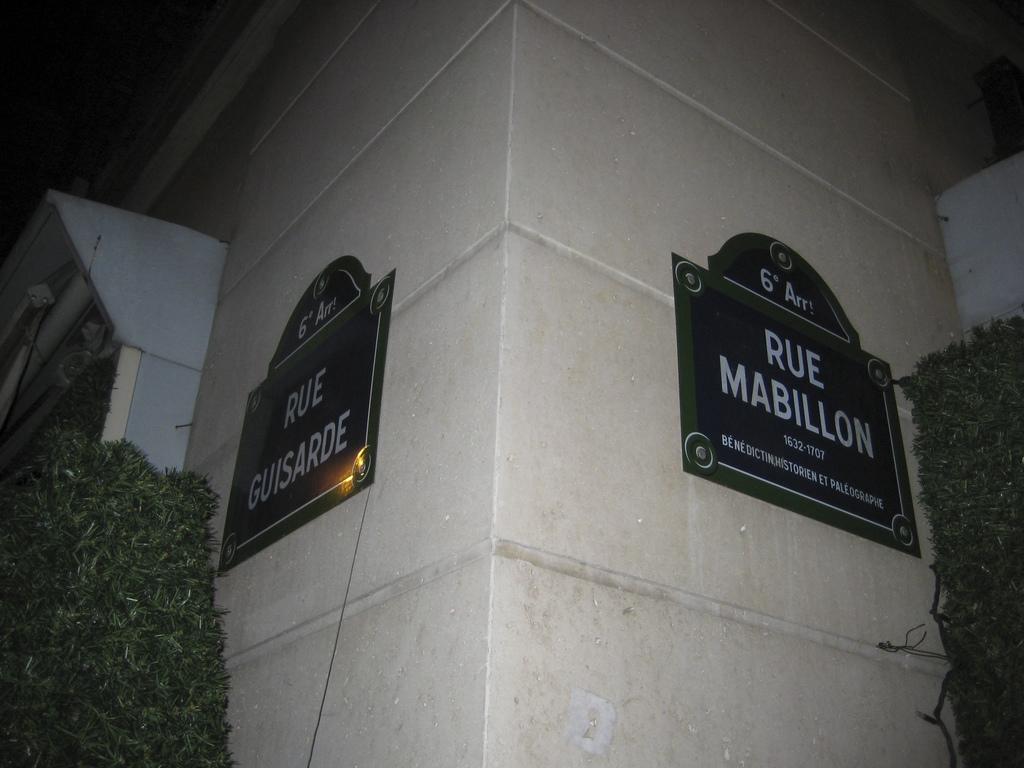Could you give a brief overview of what you see in this image? As we can see in the image there are two boards on white color wall and there are plants. The image is little dark. 